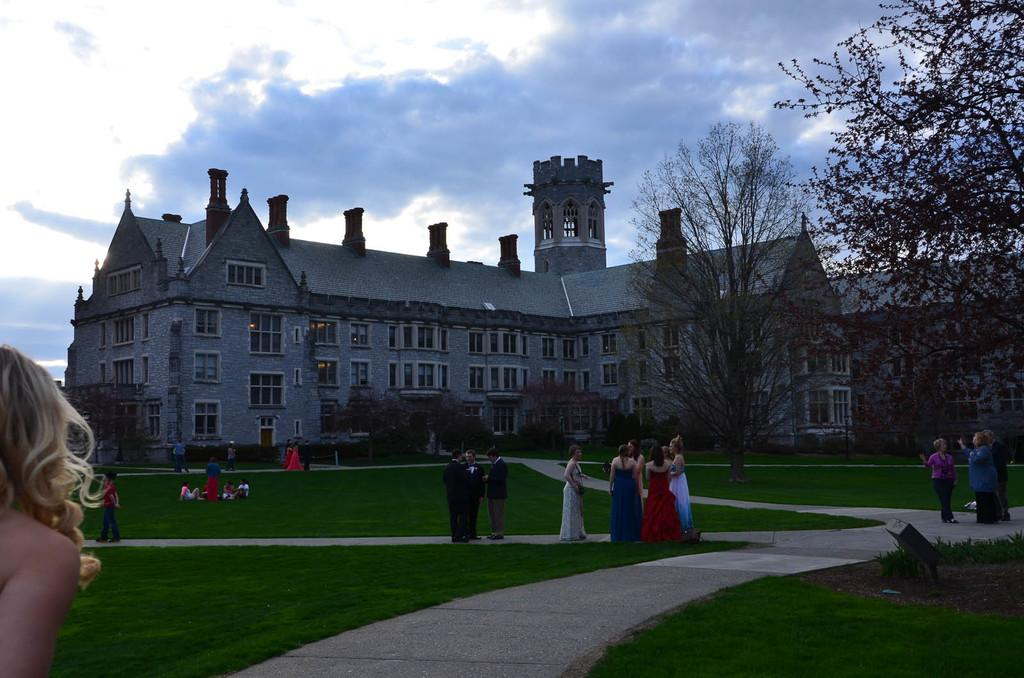What type of structures can be seen in the image? There are buildings in the image. What type of vegetation is present in the image? There are trees in the image. What are the people in the image doing? There are people standing, walking, and seated in the image. What is the ground covered with in the image? There is grass on the ground in the image. How would you describe the sky in the image? The sky is blue and cloudy in the image. What type of jelly can be seen hanging from the trees in the image? There is no jelly present in the image; it features buildings, trees, and people. How does the string connect the buildings in the image? There is no string connecting the buildings in the image; the buildings are separate structures. 